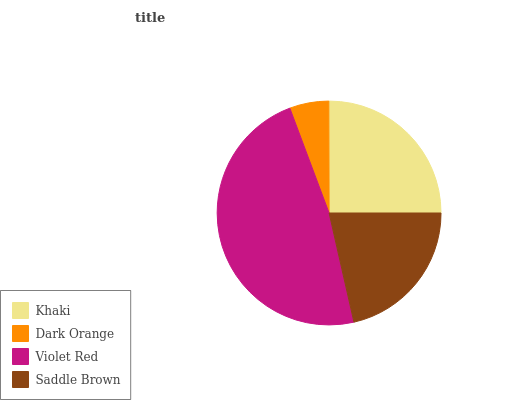Is Dark Orange the minimum?
Answer yes or no. Yes. Is Violet Red the maximum?
Answer yes or no. Yes. Is Violet Red the minimum?
Answer yes or no. No. Is Dark Orange the maximum?
Answer yes or no. No. Is Violet Red greater than Dark Orange?
Answer yes or no. Yes. Is Dark Orange less than Violet Red?
Answer yes or no. Yes. Is Dark Orange greater than Violet Red?
Answer yes or no. No. Is Violet Red less than Dark Orange?
Answer yes or no. No. Is Khaki the high median?
Answer yes or no. Yes. Is Saddle Brown the low median?
Answer yes or no. Yes. Is Dark Orange the high median?
Answer yes or no. No. Is Khaki the low median?
Answer yes or no. No. 